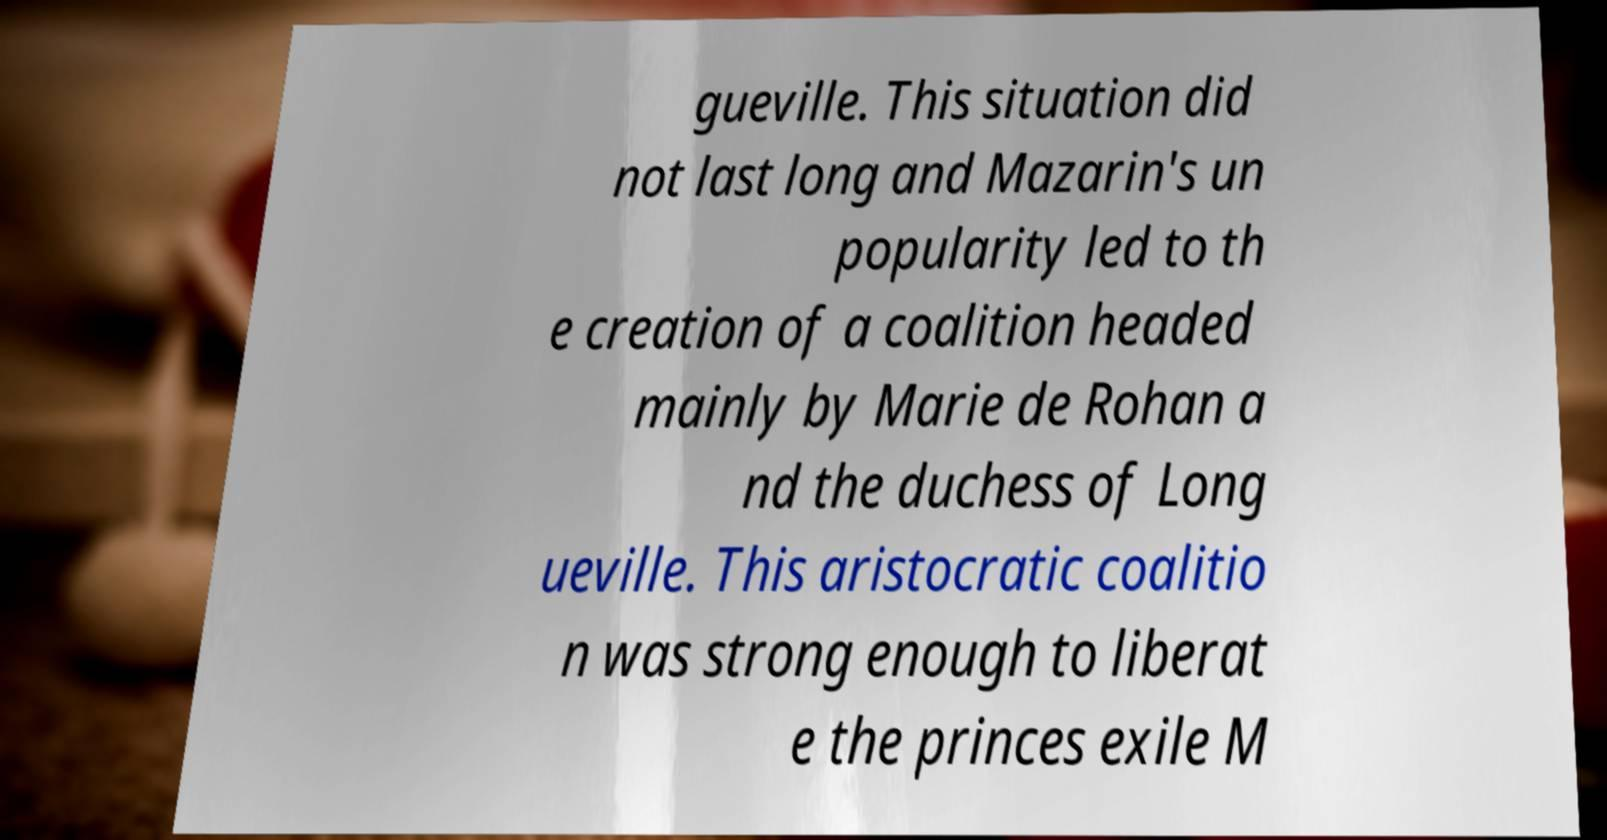What messages or text are displayed in this image? I need them in a readable, typed format. gueville. This situation did not last long and Mazarin's un popularity led to th e creation of a coalition headed mainly by Marie de Rohan a nd the duchess of Long ueville. This aristocratic coalitio n was strong enough to liberat e the princes exile M 